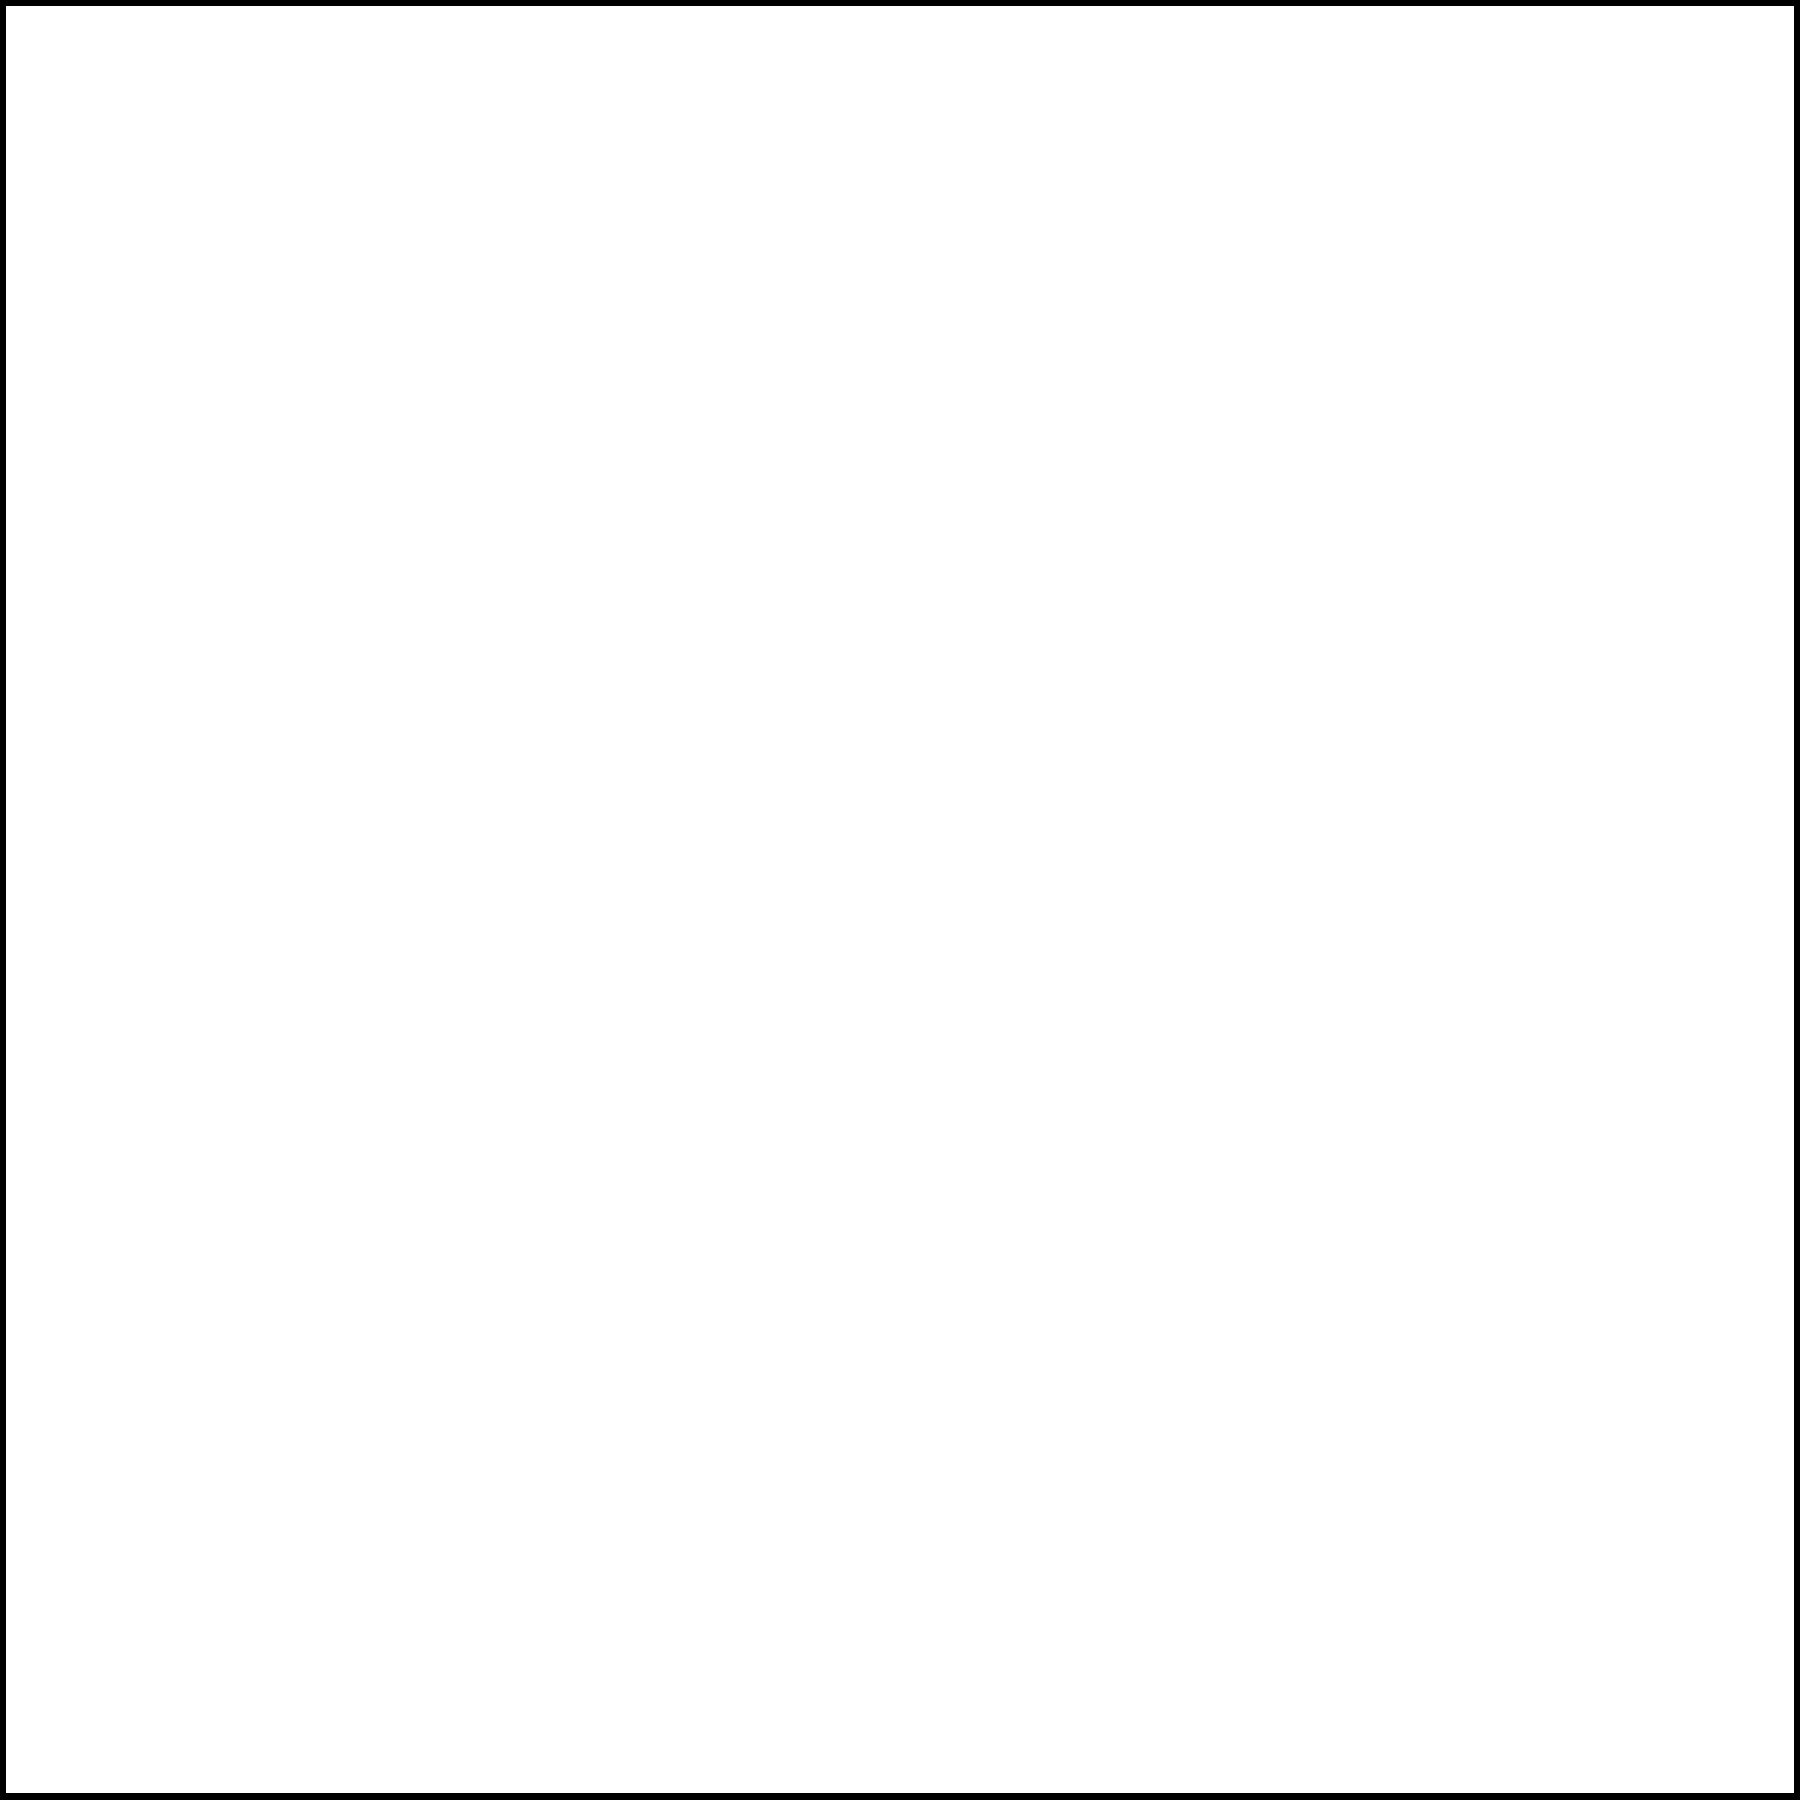In the map of Newport News, which sports field is located in the northeastern quadrant of the city? To answer this question, let's analyze the map step-by-step:

1. The map is divided into four quadrants, with the center point approximately at (50, 50).
2. The northeastern quadrant would be the upper right section of the map.
3. We can see three sports fields on the map:
   a. A green rectangular field labeled "Football" in the western part of the city.
   b. A red diamond-shaped field labeled "Baseball" in the central area.
   c. A blue rectangular field labeled "Soccer" in the northeastern part.
4. The soccer field is clearly located in the upper right corner of the map, which corresponds to the northeastern quadrant of Newport News.

Therefore, the sports field located in the northeastern quadrant of the city is the soccer field.
Answer: Soccer 